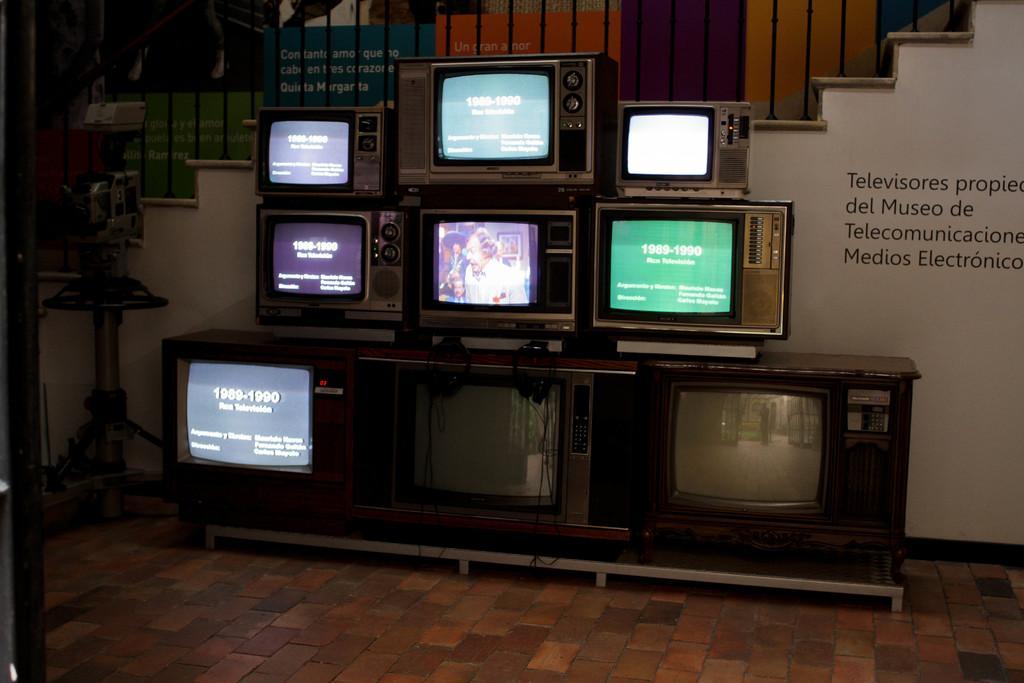How would you summarize this image in a sentence or two? In this image we can see some collection of televisions kept on the table placed on the floor. On the backside we can see some stairs and a wall. 